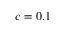Convert formula to latex. <formula><loc_0><loc_0><loc_500><loc_500>c = 0 . 1</formula> 